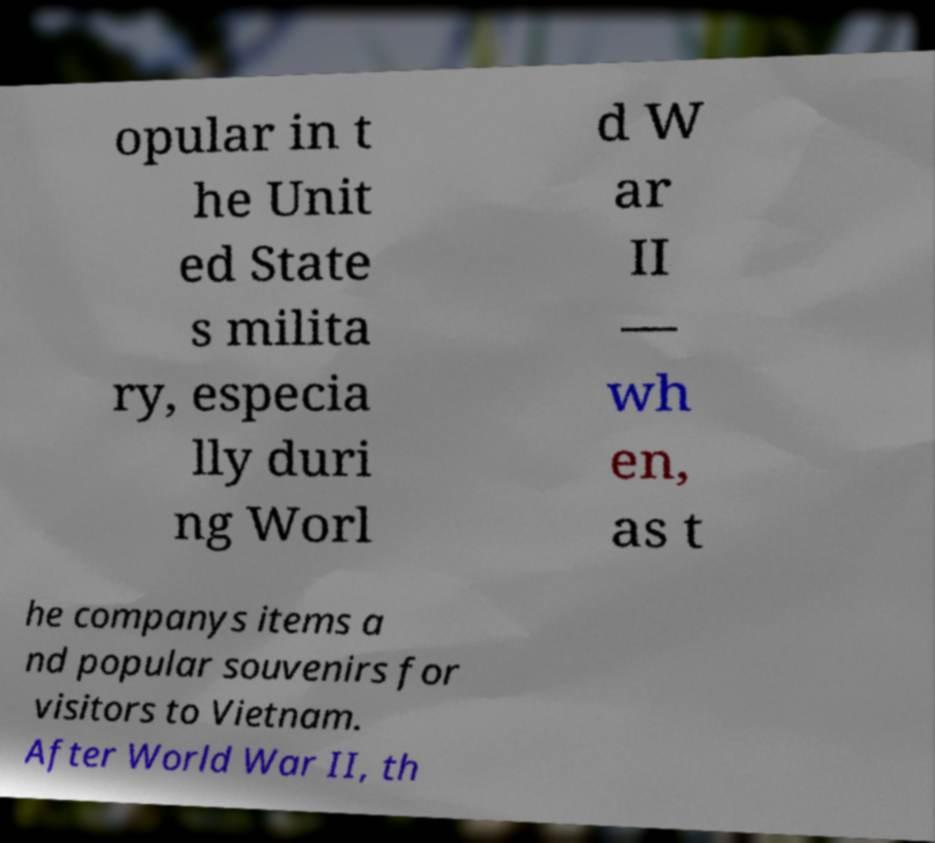Please identify and transcribe the text found in this image. opular in t he Unit ed State s milita ry, especia lly duri ng Worl d W ar II — wh en, as t he companys items a nd popular souvenirs for visitors to Vietnam. After World War II, th 